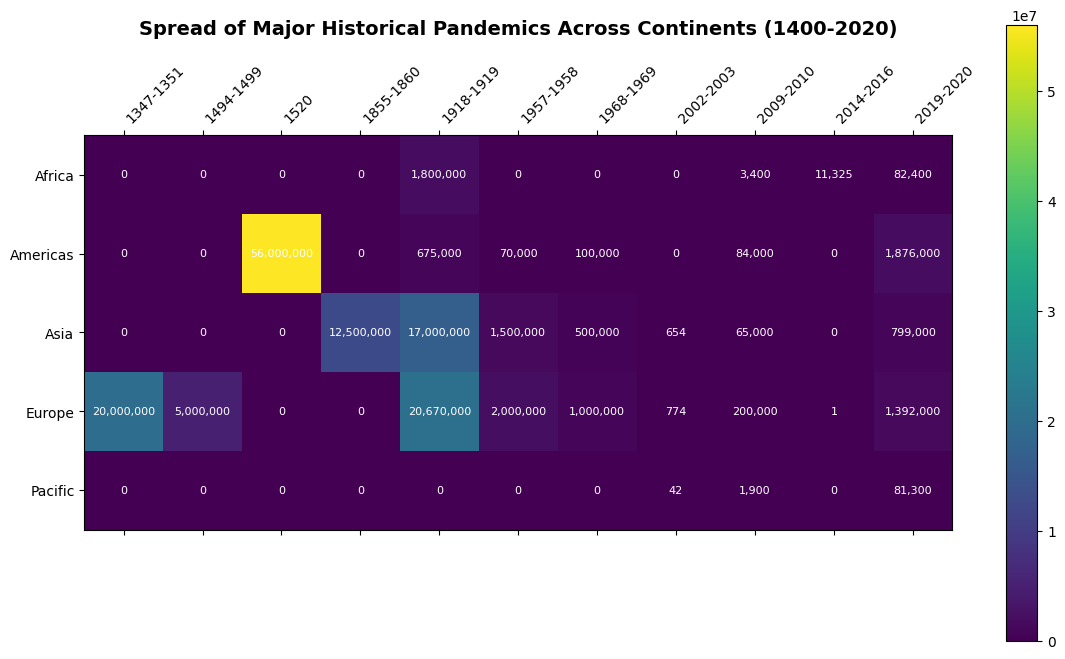What's the deadliest pandemic shown in the figure? By looking at the figure, we identify the darkest cell, which signifies the highest number of deaths. This cell is likely to be on the row representing Americas and the column around 1520. Upon identifying the exact figure, we can confirm it's Smallpox with 56,000,000 deaths.
Answer: Smallpox Which continents had multiple pandemics within the same decade? By scanning the year labels and identifying rows with darker cells clustered in the same column, we can see that Europe, Asia, and the Americas all had multiple deaths associated with pandemics in 1918-1919 (Spanish Flu) and 2009-2010 (H1N1).
Answer: Europe, Asia, Americas What's the difference in the number of deaths between the Spanish Flu in Europe and Asia during 1918-1919? Referring to the figure, locate the cells for Spanish Flu in the 1918-1919 column for Europe and Asia. Subtract the deaths in Asia from the deaths in Europe (20,670,000 - 17,000,000).
Answer: 3,670,000 Which continent experienced the lowest number of deaths from a pandemic in the 20th century, according to the figure? Locate and compare all the cells representing deaths in different continents in the 20th century. The darkest cells represent higher deaths, and the lightest cells show lower deaths. The lowest seems to be Pacific in the SARS pandemic with 42 deaths.
Answer: Pacific Which pandemic significantly affected the Americas twice in different centuries? Identify the clusters of death data by following timelines for the Americas. Smallpox (1520) and COVID-19 (2019-2020) show significant spikes in deaths in two different centuries – 16th and 21st centuries.
Answer: Smallpox and COVID-19 What is the total number of deaths caused by pandemics in Europe and Asia in the 1968-1969 period? Locate the cells for Europe and Asia in the 1968-1969 column and sum the numbers (1,000,000 + 500,000).
Answer: 1,500,000 Compare the impact of the 1918-1919 Spanish Flu between Europe and Africa. Which continent suffered more? Look at the cells for Spanish Flu in the 1918-1919 column and compare the deaths in Europe (20,670,000) and Africa (1,800,000). Europe has a significantly higher death toll.
Answer: Europe Which pandemic had the highest death toll in the Pacific region? Find the row for the Pacific region and check which cell has the darkest shade indicating the highest deaths, which in this case is COVID-19 (2019-2020).
Answer: COVID-19 